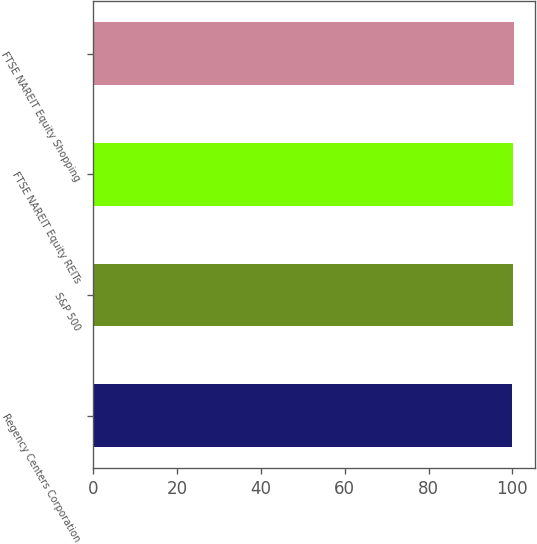Convert chart to OTSL. <chart><loc_0><loc_0><loc_500><loc_500><bar_chart><fcel>Regency Centers Corporation<fcel>S&P 500<fcel>FTSE NAREIT Equity REITs<fcel>FTSE NAREIT Equity Shopping<nl><fcel>100<fcel>100.1<fcel>100.2<fcel>100.3<nl></chart> 